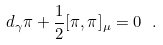Convert formula to latex. <formula><loc_0><loc_0><loc_500><loc_500>d _ { \gamma } \pi + \frac { 1 } { 2 } [ { \pi } , { \pi } ] _ { \mu } = 0 \ .</formula> 